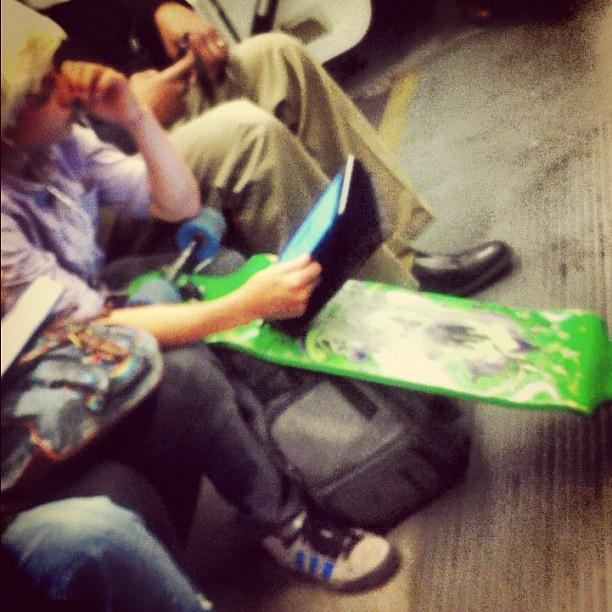What device is the boy holding?

Choices:
A) television
B) smartphone
C) laptop
D) tablet tablet 